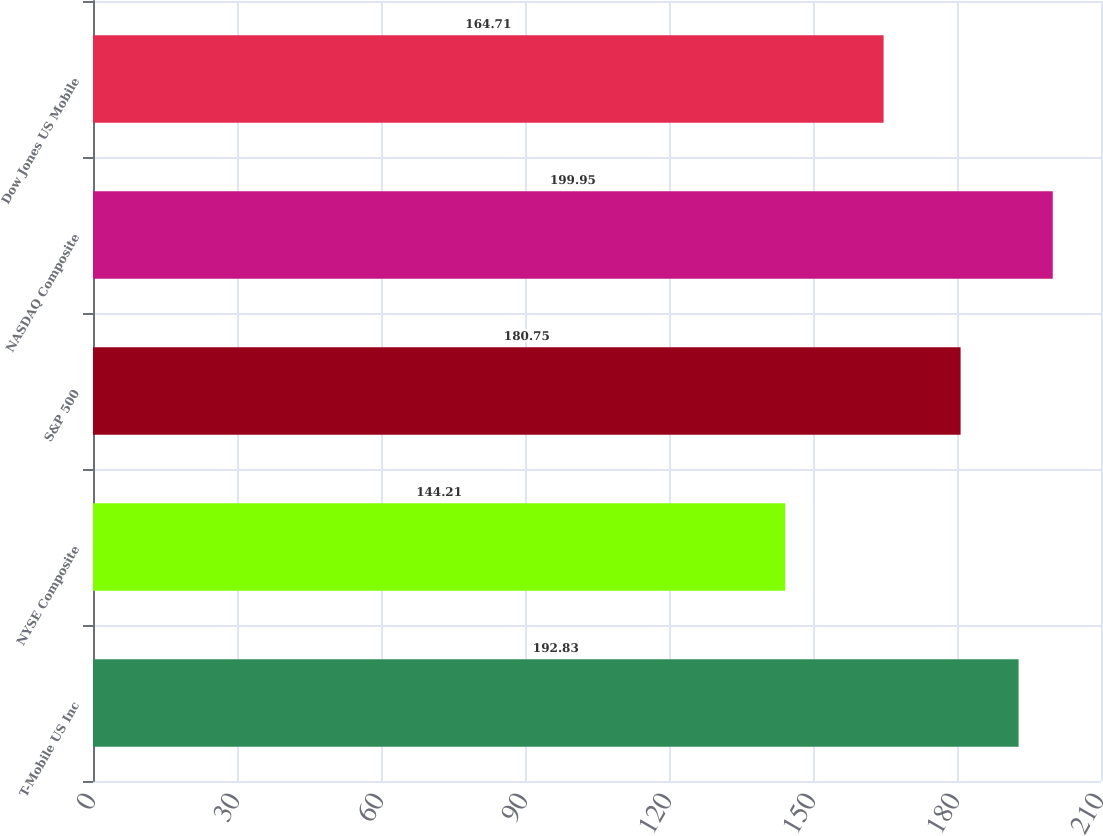Convert chart to OTSL. <chart><loc_0><loc_0><loc_500><loc_500><bar_chart><fcel>T-Mobile US Inc<fcel>NYSE Composite<fcel>S&P 500<fcel>NASDAQ Composite<fcel>Dow Jones US Mobile<nl><fcel>192.83<fcel>144.21<fcel>180.75<fcel>199.95<fcel>164.71<nl></chart> 